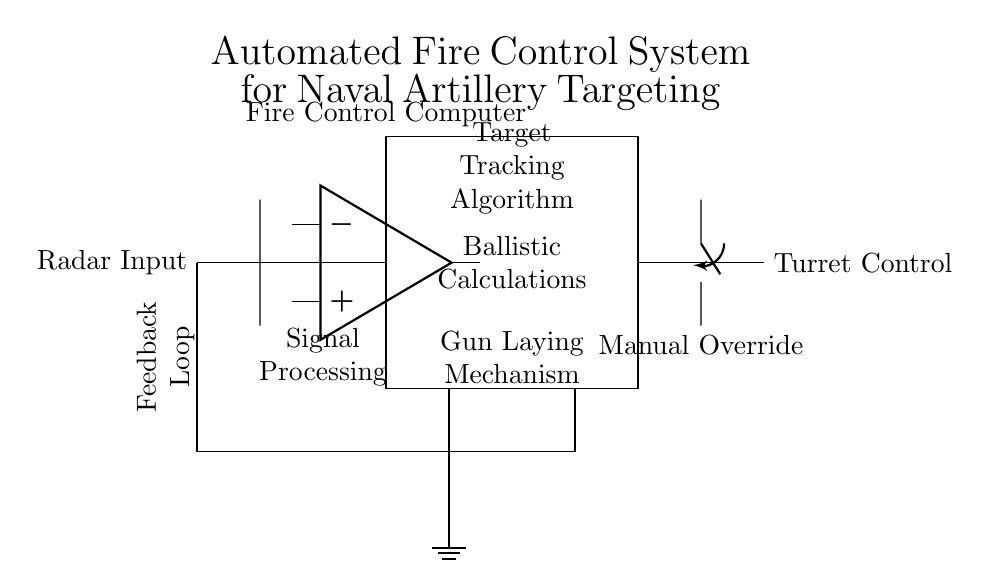What is the main function of the fire control computer? The fire control computer processes incoming radar signals, performs ballistic calculations, and outputs commands to the turret control for directing artillery fire.
Answer: Target tracking and ballistic calculations What component is used for manual control? The circuit diagram displays a manual override switch that enables operators to take control of the artillery system if needed.
Answer: Manual override What type of feedback mechanism is illustrated? The feedback loop connects various components to allow the system to adjust actions based on the radar input and firing results, ensuring accuracy in targeting.
Answer: Feedback loop What are the four main processes within the fire control computer? The processes include target tracking algorithm, ballistic calculations, gun laying mechanism, and signal processing, each contributing to effective artillery control.
Answer: Target tracking, ballistic calculations, gun laying mechanism, signal processing How does the feedback loop influence artillery performance? The feedback loop utilizes data from the artillery system and radar input to refine aim, adjust for any discrepancies, and enhance targeting precision over time.
Answer: Adjusts aim and enhances targeting precision 